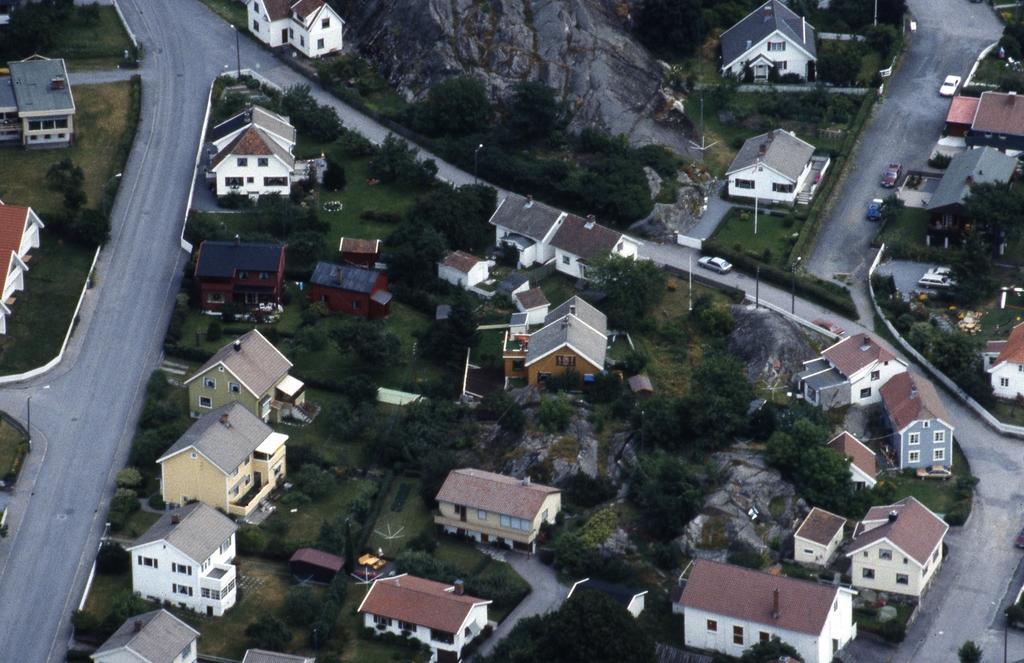Please provide a concise description of this image. In this picture i can see many house, building, trees, plants and grass. At the top there is a mountain. On the left i can see the roads, beside that i can see the street lights. 